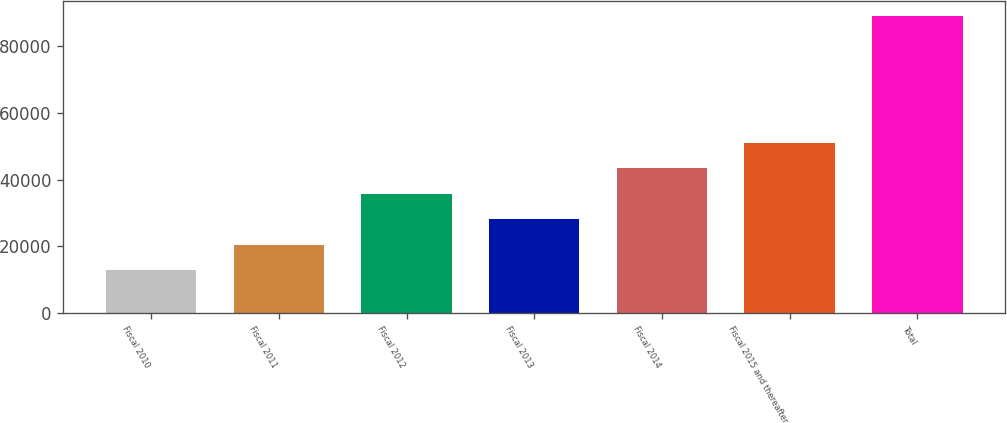Convert chart. <chart><loc_0><loc_0><loc_500><loc_500><bar_chart><fcel>Fiscal 2010<fcel>Fiscal 2011<fcel>Fiscal 2012<fcel>Fiscal 2013<fcel>Fiscal 2014<fcel>Fiscal 2015 and thereafter<fcel>Total<nl><fcel>12780<fcel>20426.4<fcel>35719.2<fcel>28072.8<fcel>43365.6<fcel>51012<fcel>89244<nl></chart> 